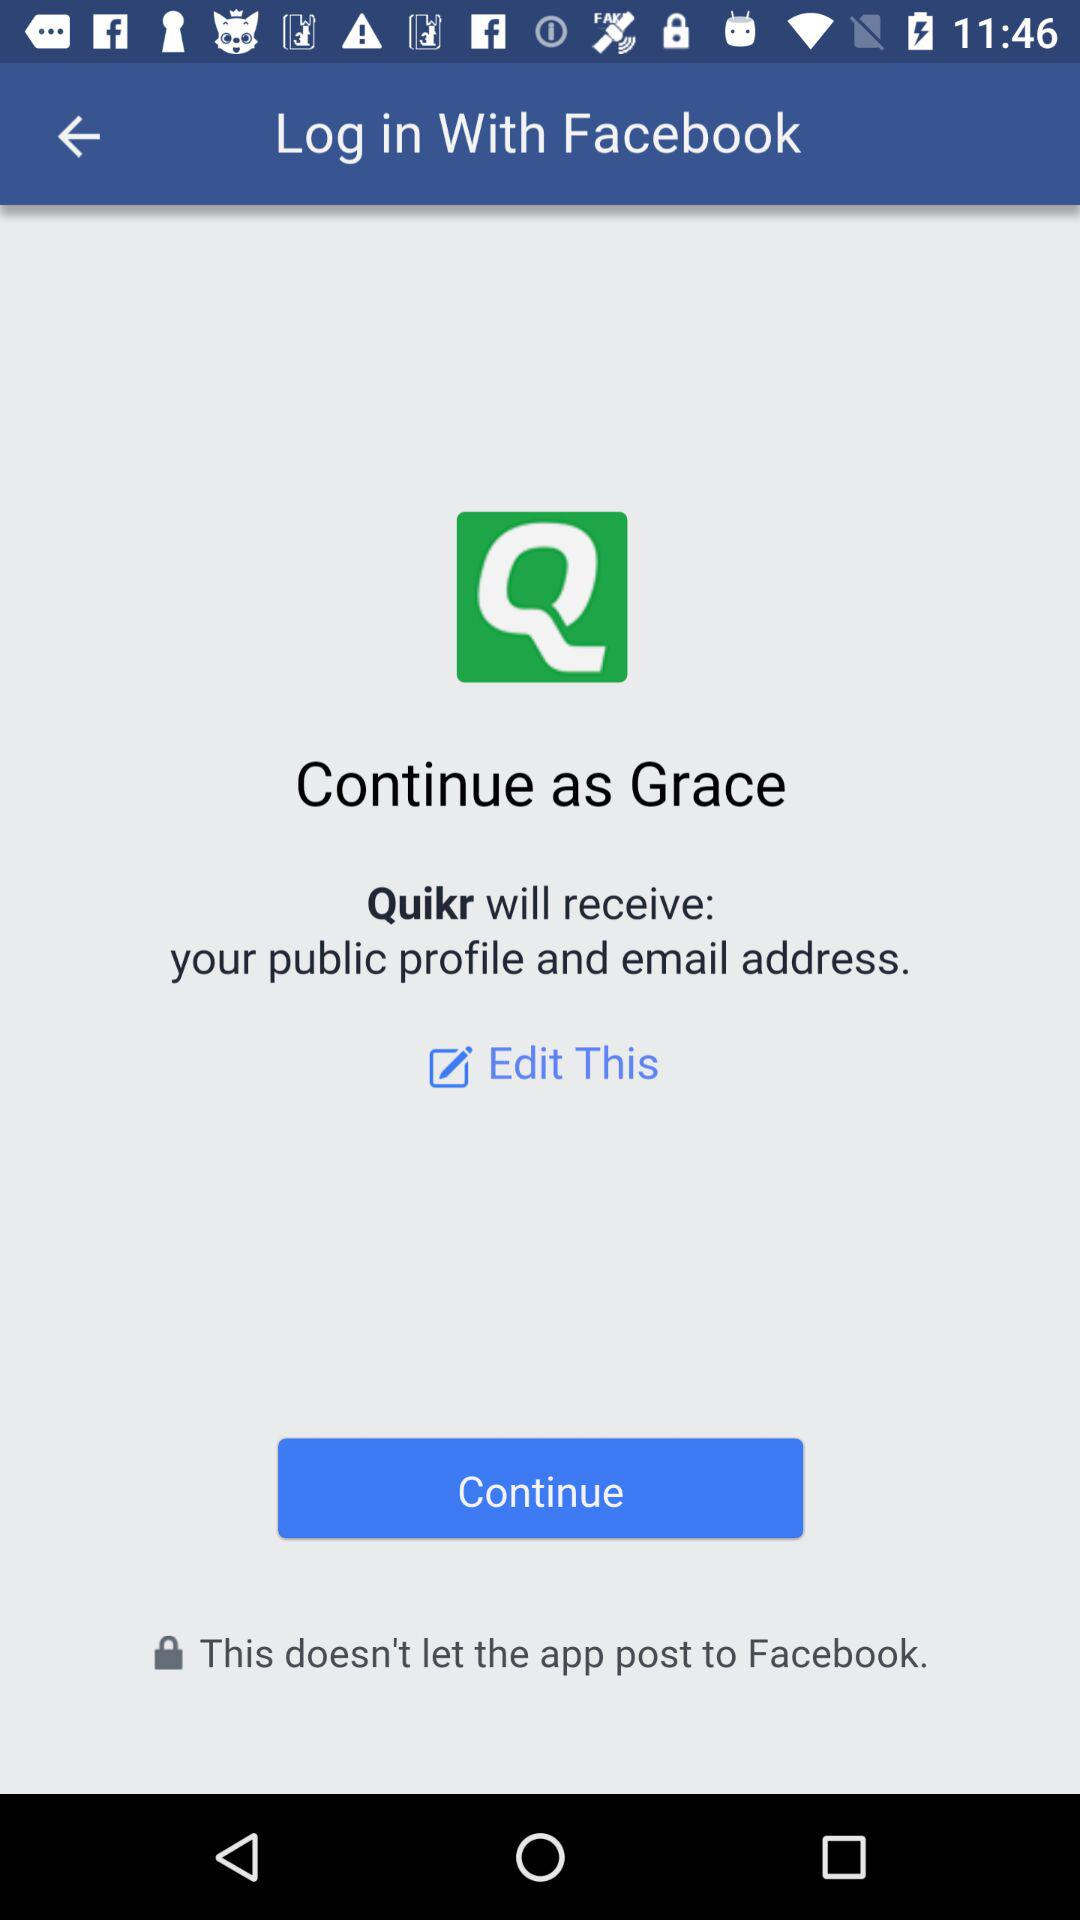Through what account log in can be done? We can log in through "Facebook". 